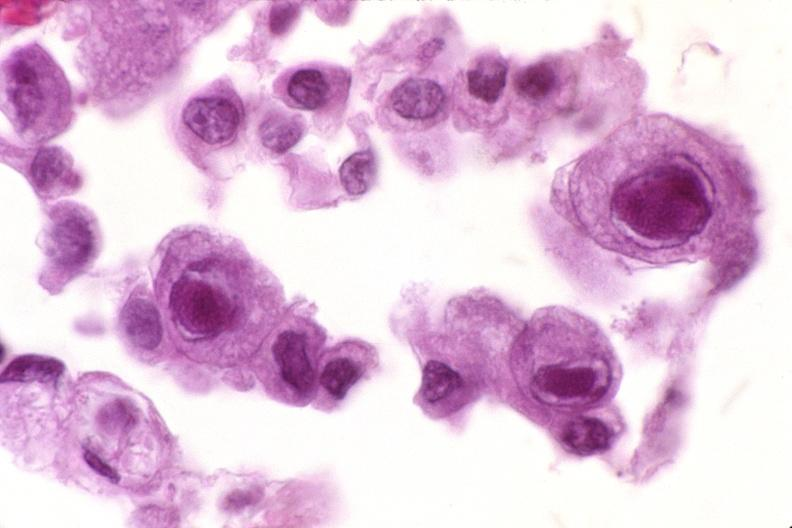what does this image show?
Answer the question using a single word or phrase. Lung 